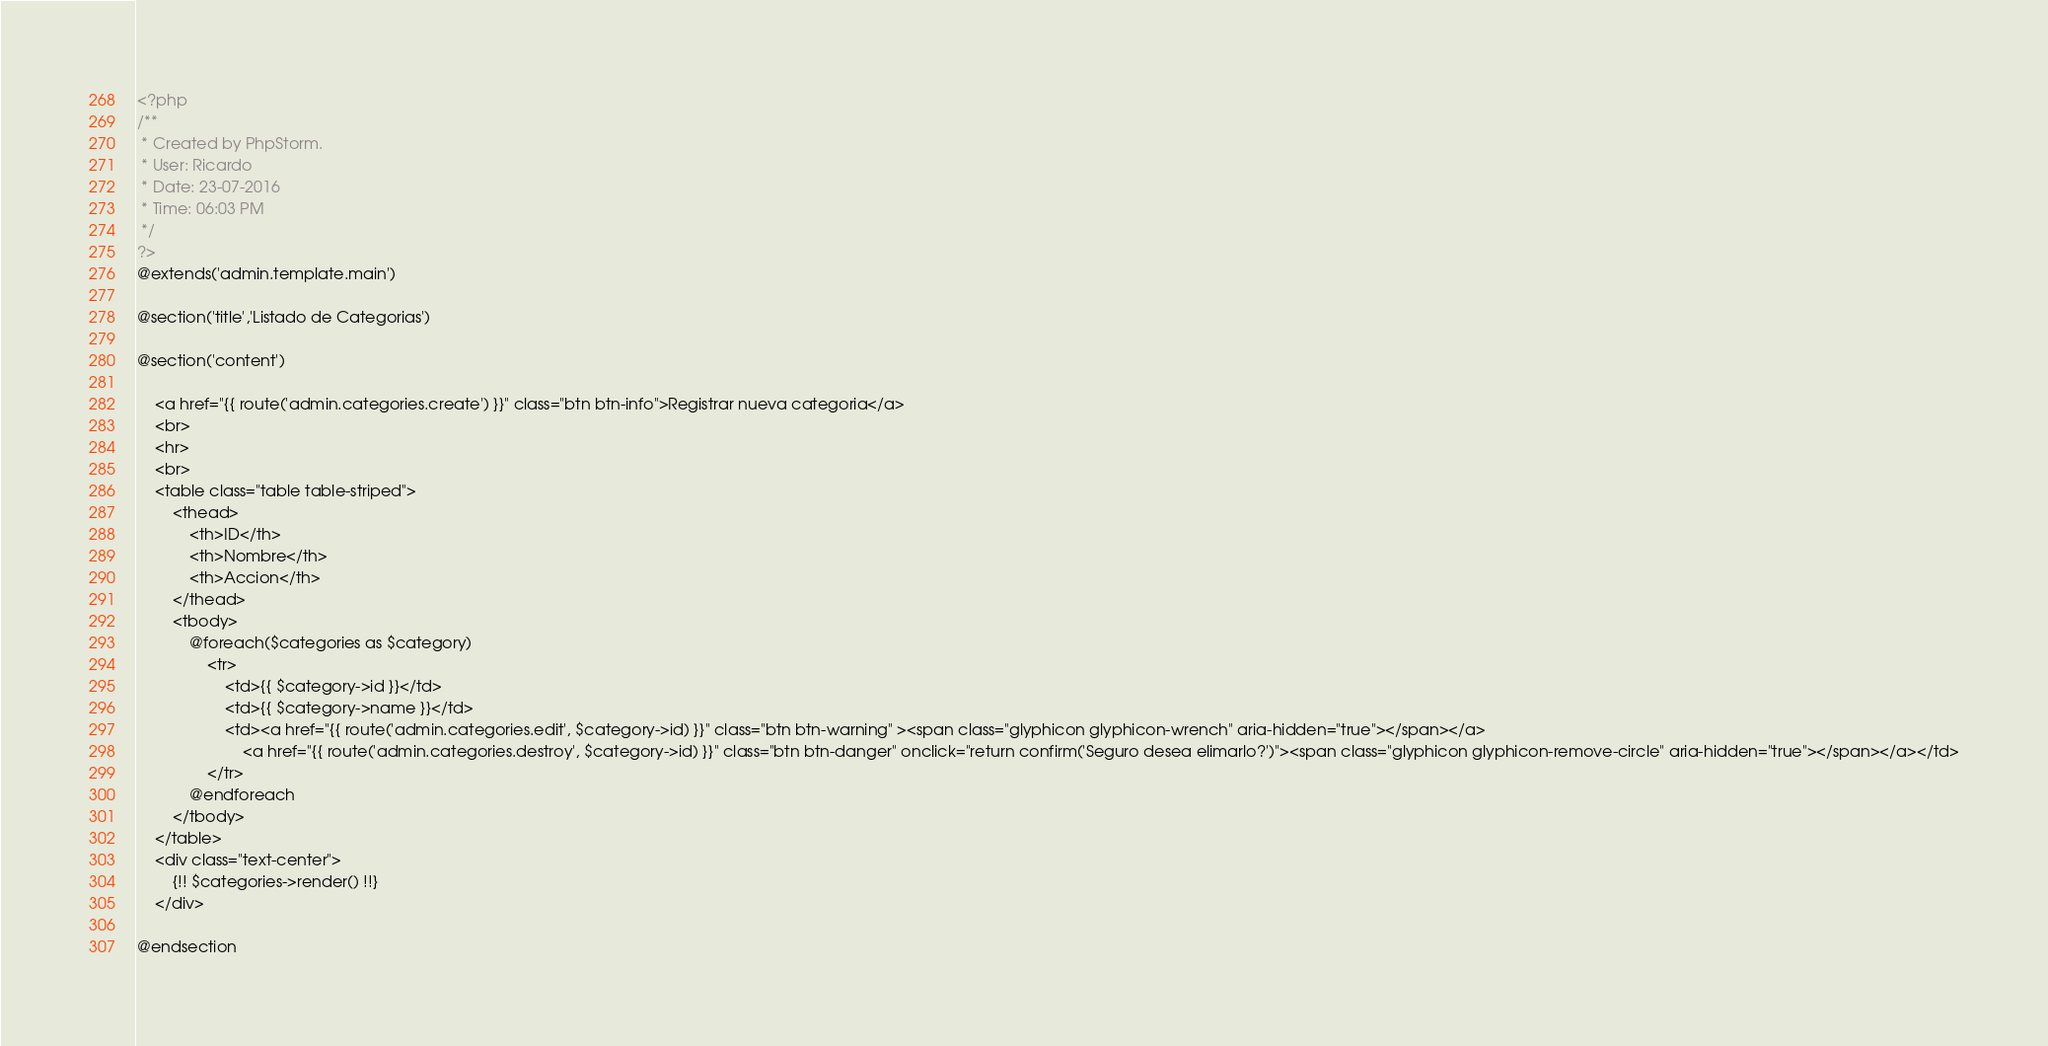Convert code to text. <code><loc_0><loc_0><loc_500><loc_500><_PHP_><?php
/**
 * Created by PhpStorm.
 * User: Ricardo
 * Date: 23-07-2016
 * Time: 06:03 PM
 */
?>
@extends('admin.template.main')

@section('title','Listado de Categorias')

@section('content')

    <a href="{{ route('admin.categories.create') }}" class="btn btn-info">Registrar nueva categoria</a>
    <br>
    <hr>
    <br>
    <table class="table table-striped">
        <thead>
            <th>ID</th>
            <th>Nombre</th>
            <th>Accion</th>
        </thead>
        <tbody>
            @foreach($categories as $category)
                <tr>
                    <td>{{ $category->id }}</td>
                    <td>{{ $category->name }}</td>
                    <td><a href="{{ route('admin.categories.edit', $category->id) }}" class="btn btn-warning" ><span class="glyphicon glyphicon-wrench" aria-hidden="true"></span></a>
                        <a href="{{ route('admin.categories.destroy', $category->id) }}" class="btn btn-danger" onclick="return confirm('Seguro desea elimarlo?')"><span class="glyphicon glyphicon-remove-circle" aria-hidden="true"></span></a></td>
                </tr>
            @endforeach
        </tbody>
    </table>
    <div class="text-center">
        {!! $categories->render() !!}
    </div>

@endsection
</code> 